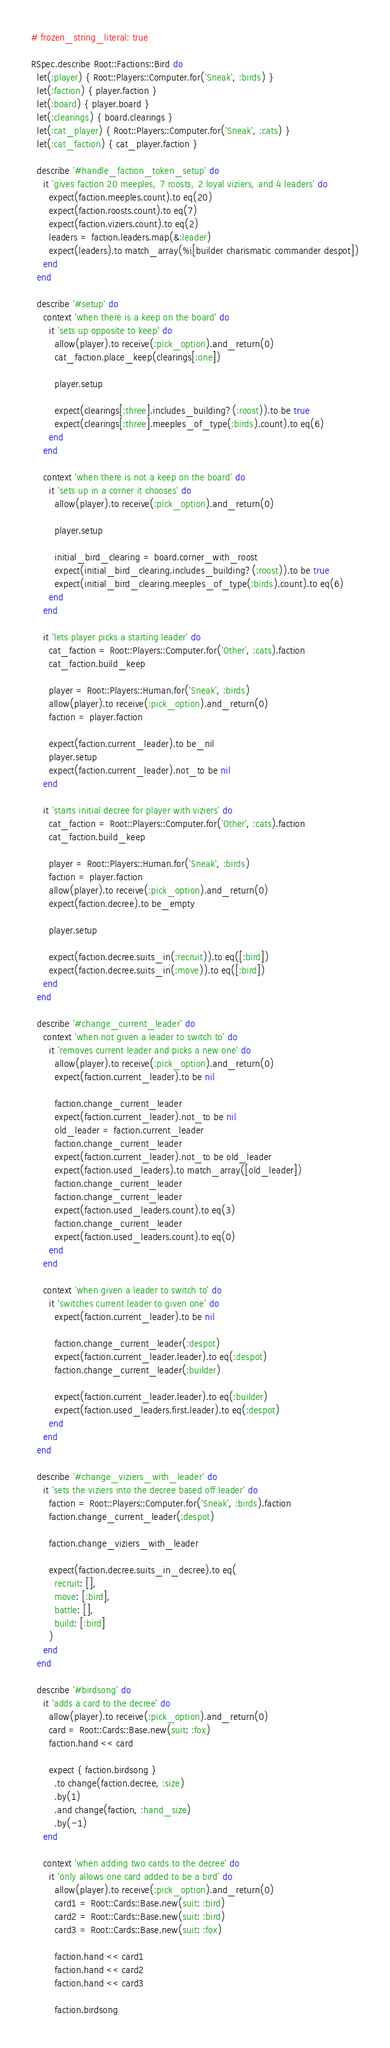<code> <loc_0><loc_0><loc_500><loc_500><_Ruby_># frozen_string_literal: true

RSpec.describe Root::Factions::Bird do
  let(:player) { Root::Players::Computer.for('Sneak', :birds) }
  let(:faction) { player.faction }
  let(:board) { player.board }
  let(:clearings) { board.clearings }
  let(:cat_player) { Root::Players::Computer.for('Sneak', :cats) }
  let(:cat_faction) { cat_player.faction }

  describe '#handle_faction_token_setup' do
    it 'gives faction 20 meeples, 7 roosts, 2 loyal viziers, and 4 leaders' do
      expect(faction.meeples.count).to eq(20)
      expect(faction.roosts.count).to eq(7)
      expect(faction.viziers.count).to eq(2)
      leaders = faction.leaders.map(&:leader)
      expect(leaders).to match_array(%i[builder charismatic commander despot])
    end
  end

  describe '#setup' do
    context 'when there is a keep on the board' do
      it 'sets up opposite to keep' do
        allow(player).to receive(:pick_option).and_return(0)
        cat_faction.place_keep(clearings[:one])

        player.setup

        expect(clearings[:three].includes_building?(:roost)).to be true
        expect(clearings[:three].meeples_of_type(:birds).count).to eq(6)
      end
    end

    context 'when there is not a keep on the board' do
      it 'sets up in a corner it chooses' do
        allow(player).to receive(:pick_option).and_return(0)

        player.setup

        initial_bird_clearing = board.corner_with_roost
        expect(initial_bird_clearing.includes_building?(:roost)).to be true
        expect(initial_bird_clearing.meeples_of_type(:birds).count).to eq(6)
      end
    end

    it 'lets player picks a starting leader' do
      cat_faction = Root::Players::Computer.for('Other', :cats).faction
      cat_faction.build_keep

      player = Root::Players::Human.for('Sneak', :birds)
      allow(player).to receive(:pick_option).and_return(0)
      faction = player.faction

      expect(faction.current_leader).to be_nil
      player.setup
      expect(faction.current_leader).not_to be nil
    end

    it 'starts initial decree for player with viziers' do
      cat_faction = Root::Players::Computer.for('Other', :cats).faction
      cat_faction.build_keep

      player = Root::Players::Human.for('Sneak', :birds)
      faction = player.faction
      allow(player).to receive(:pick_option).and_return(0)
      expect(faction.decree).to be_empty

      player.setup

      expect(faction.decree.suits_in(:recruit)).to eq([:bird])
      expect(faction.decree.suits_in(:move)).to eq([:bird])
    end
  end

  describe '#change_current_leader' do
    context 'when not given a leader to switch to' do
      it 'removes current leader and picks a new one' do
        allow(player).to receive(:pick_option).and_return(0)
        expect(faction.current_leader).to be nil

        faction.change_current_leader
        expect(faction.current_leader).not_to be nil
        old_leader = faction.current_leader
        faction.change_current_leader
        expect(faction.current_leader).not_to be old_leader
        expect(faction.used_leaders).to match_array([old_leader])
        faction.change_current_leader
        faction.change_current_leader
        expect(faction.used_leaders.count).to eq(3)
        faction.change_current_leader
        expect(faction.used_leaders.count).to eq(0)
      end
    end

    context 'when given a leader to switch to' do
      it 'switches current leader to given one' do
        expect(faction.current_leader).to be nil

        faction.change_current_leader(:despot)
        expect(faction.current_leader.leader).to eq(:despot)
        faction.change_current_leader(:builder)

        expect(faction.current_leader.leader).to eq(:builder)
        expect(faction.used_leaders.first.leader).to eq(:despot)
      end
    end
  end

  describe '#change_viziers_with_leader' do
    it 'sets the viziers into the decree based off leader' do
      faction = Root::Players::Computer.for('Sneak', :birds).faction
      faction.change_current_leader(:despot)

      faction.change_viziers_with_leader

      expect(faction.decree.suits_in_decree).to eq(
        recruit: [],
        move: [:bird],
        battle: [],
        build: [:bird]
      )
    end
  end

  describe '#birdsong' do
    it 'adds a card to the decree' do
      allow(player).to receive(:pick_option).and_return(0)
      card = Root::Cards::Base.new(suit: :fox)
      faction.hand << card

      expect { faction.birdsong }
        .to change(faction.decree, :size)
        .by(1)
        .and change(faction, :hand_size)
        .by(-1)
    end

    context 'when adding two cards to the decree' do
      it 'only allows one card added to be a bird' do
        allow(player).to receive(:pick_option).and_return(0)
        card1 = Root::Cards::Base.new(suit: :bird)
        card2 = Root::Cards::Base.new(suit: :bird)
        card3 = Root::Cards::Base.new(suit: :fox)

        faction.hand << card1
        faction.hand << card2
        faction.hand << card3

        faction.birdsong
</code> 